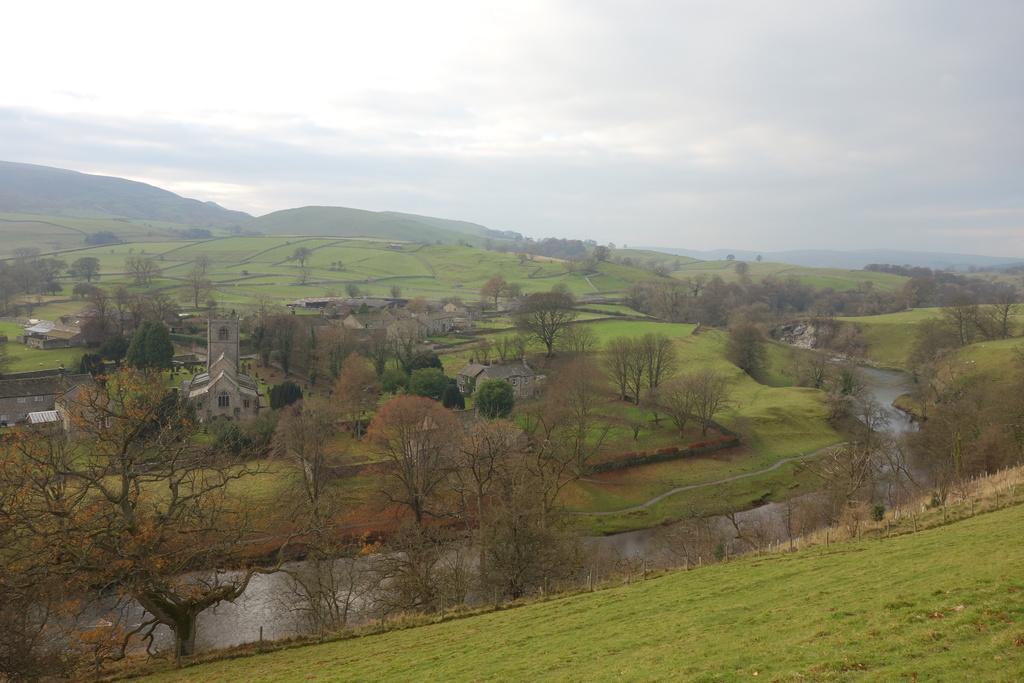Could you give a brief overview of what you see in this image? In the picture I can see trees, the grass, the water and buildings. In the background I can see hills and the sky. 